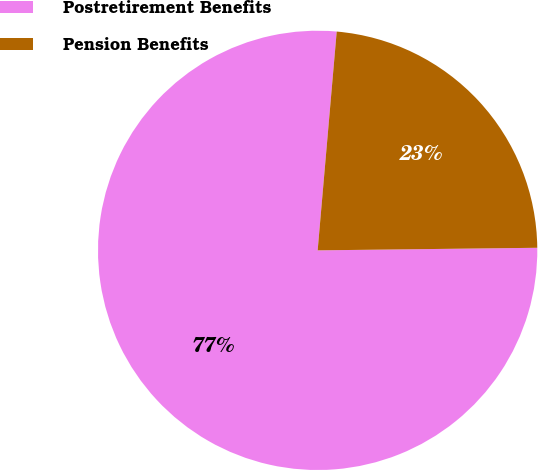<chart> <loc_0><loc_0><loc_500><loc_500><pie_chart><fcel>Postretirement Benefits<fcel>Pension Benefits<nl><fcel>76.57%<fcel>23.43%<nl></chart> 